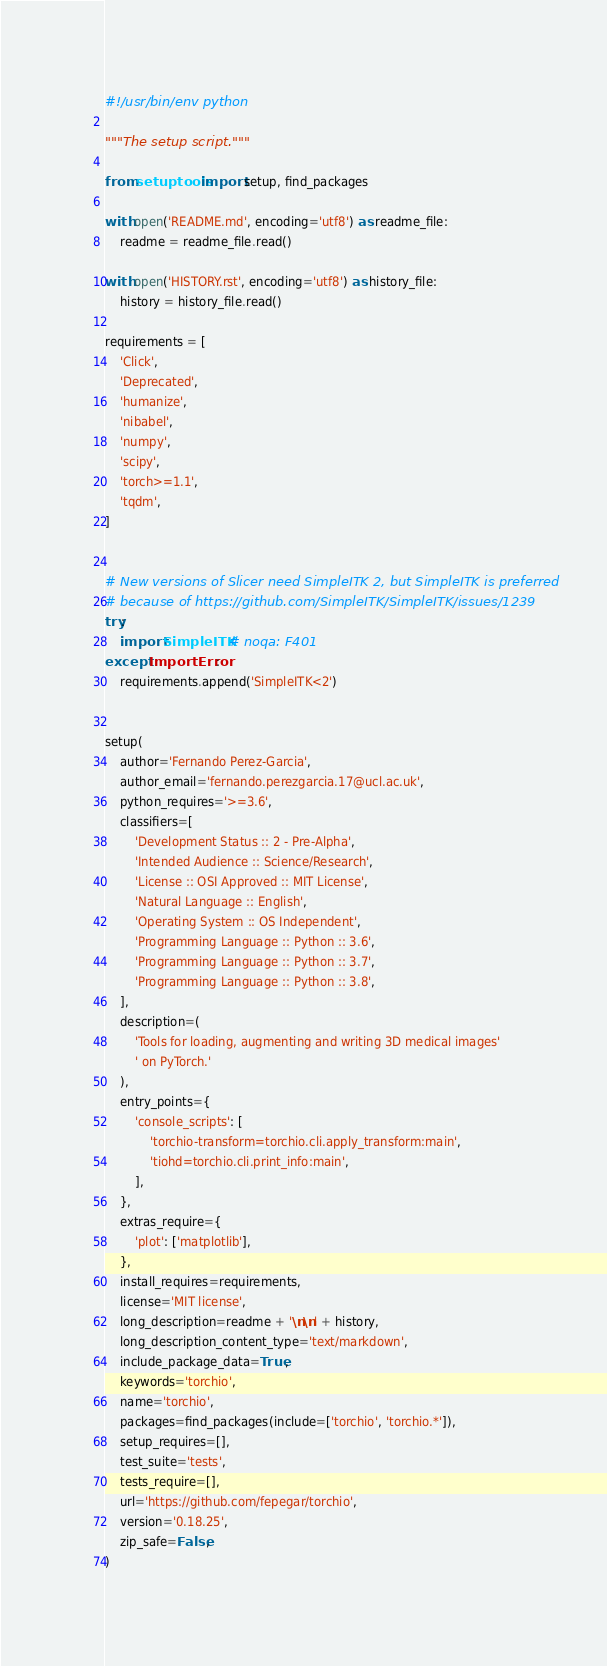Convert code to text. <code><loc_0><loc_0><loc_500><loc_500><_Python_>#!/usr/bin/env python

"""The setup script."""

from setuptools import setup, find_packages

with open('README.md', encoding='utf8') as readme_file:
    readme = readme_file.read()

with open('HISTORY.rst', encoding='utf8') as history_file:
    history = history_file.read()

requirements = [
    'Click',
    'Deprecated',
    'humanize',
    'nibabel',
    'numpy',
    'scipy',
    'torch>=1.1',
    'tqdm',
]


# New versions of Slicer need SimpleITK 2, but SimpleITK is preferred
# because of https://github.com/SimpleITK/SimpleITK/issues/1239
try:
    import SimpleITK  # noqa: F401
except ImportError:
    requirements.append('SimpleITK<2')


setup(
    author='Fernando Perez-Garcia',
    author_email='fernando.perezgarcia.17@ucl.ac.uk',
    python_requires='>=3.6',
    classifiers=[
        'Development Status :: 2 - Pre-Alpha',
        'Intended Audience :: Science/Research',
        'License :: OSI Approved :: MIT License',
        'Natural Language :: English',
        'Operating System :: OS Independent',
        'Programming Language :: Python :: 3.6',
        'Programming Language :: Python :: 3.7',
        'Programming Language :: Python :: 3.8',
    ],
    description=(
        'Tools for loading, augmenting and writing 3D medical images'
        ' on PyTorch.'
    ),
    entry_points={
        'console_scripts': [
            'torchio-transform=torchio.cli.apply_transform:main',
            'tiohd=torchio.cli.print_info:main',
        ],
    },
    extras_require={
        'plot': ['matplotlib'],
    },
    install_requires=requirements,
    license='MIT license',
    long_description=readme + '\n\n' + history,
    long_description_content_type='text/markdown',
    include_package_data=True,
    keywords='torchio',
    name='torchio',
    packages=find_packages(include=['torchio', 'torchio.*']),
    setup_requires=[],
    test_suite='tests',
    tests_require=[],
    url='https://github.com/fepegar/torchio',
    version='0.18.25',
    zip_safe=False,
)
</code> 